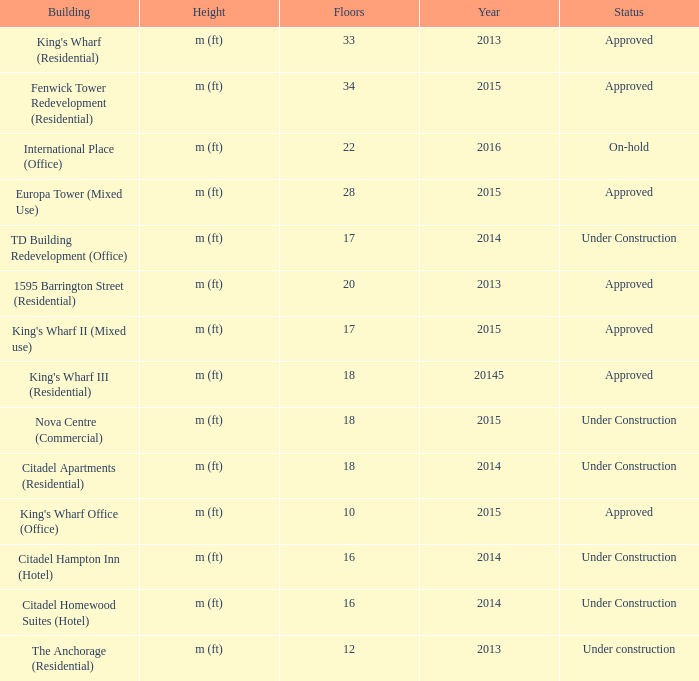How many floors does the td building redevelopment (office) have? 17.0. 